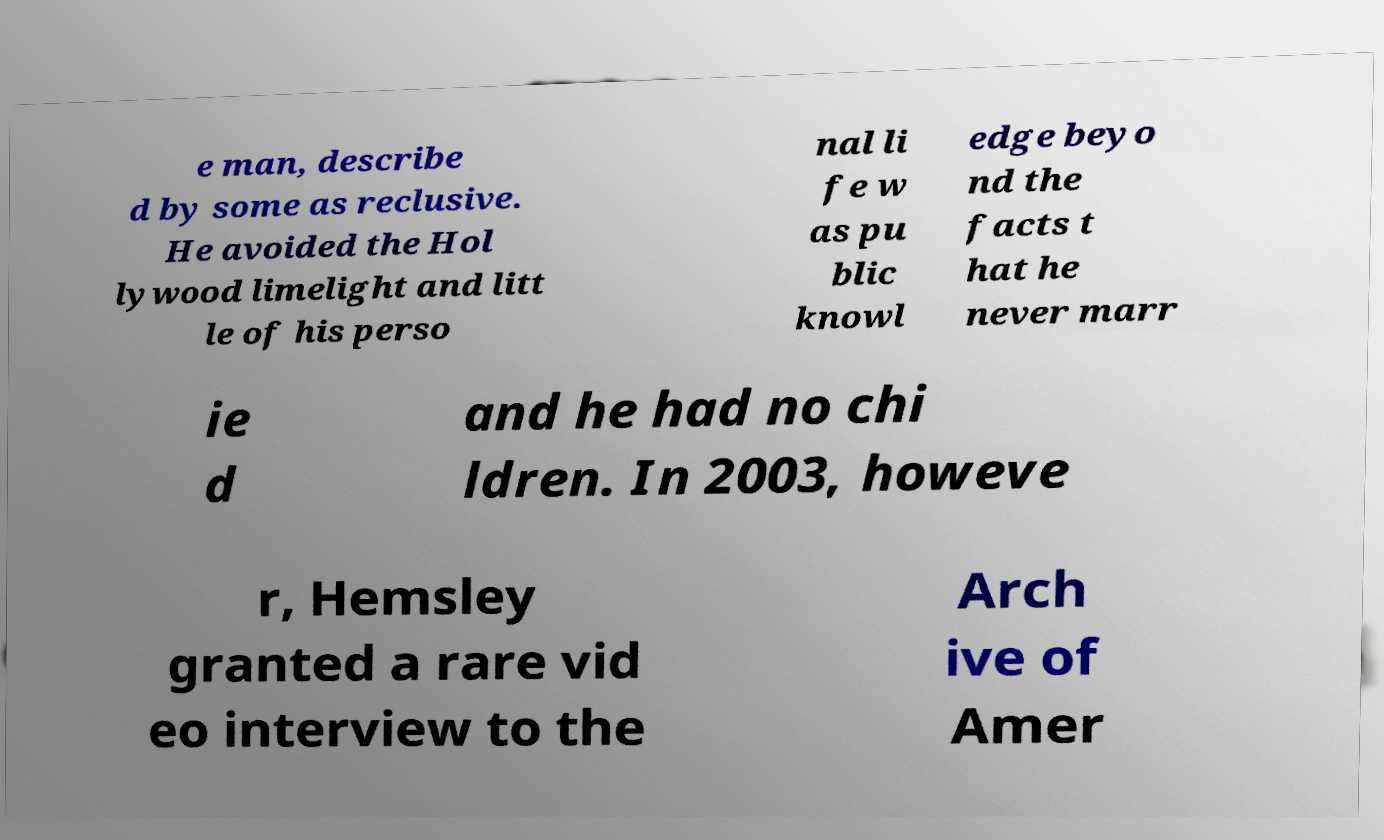For documentation purposes, I need the text within this image transcribed. Could you provide that? e man, describe d by some as reclusive. He avoided the Hol lywood limelight and litt le of his perso nal li fe w as pu blic knowl edge beyo nd the facts t hat he never marr ie d and he had no chi ldren. In 2003, howeve r, Hemsley granted a rare vid eo interview to the Arch ive of Amer 